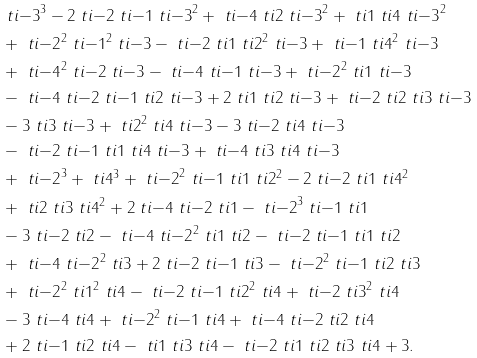Convert formula to latex. <formula><loc_0><loc_0><loc_500><loc_500>& \ t i { - 3 } ^ { 3 } - 2 \ t i { - 2 } \ t i { - 1 } \ t i { - 3 } ^ { 2 } + \ t i { - 4 } \ t i { 2 } \ t i { - 3 } ^ { 2 } + \ t i { 1 } \ t i { 4 } \ t i { - 3 } ^ { 2 } \\ & + \ t i { - 2 } ^ { 2 } \ t i { - 1 } ^ { 2 } \ t i { - 3 } - \ t i { - 2 } \ t i { 1 } \ t i { 2 } ^ { 2 } \ t i { - 3 } + \ t i { - 1 } \ t i { 4 } ^ { 2 } \ t i { - 3 } \\ & + \ t i { - 4 } ^ { 2 } \ t i { - 2 } \ t i { - 3 } - \ t i { - 4 } \ t i { - 1 } \ t i { - 3 } + \ t i { - 2 } ^ { 2 } \ t i { 1 } \ t i { - 3 } \\ & - \ t i { - 4 } \ t i { - 2 } \ t i { - 1 } \ t i { 2 } \ t i { - 3 } + 2 \ t i { 1 } \ t i { 2 } \ t i { - 3 } + \ t i { - 2 } \ t i { 2 } \ t i { 3 } \ t i { - 3 } \\ & - 3 \ t i { 3 } \ t i { - 3 } + \ t i { 2 } ^ { 2 } \ t i { 4 } \ t i { - 3 } - 3 \ t i { - 2 } \ t i { 4 } \ t i { - 3 } \\ & - \ t i { - 2 } \ t i { - 1 } \ t i { 1 } \ t i { 4 } \ t i { - 3 } + \ t i { - 4 } \ t i { 3 } \ t i { 4 } \ t i { - 3 } \\ & + \ t i { - 2 } ^ { 3 } + \ t i { 4 } ^ { 3 } + \ t i { - 2 } ^ { 2 } \ t i { - 1 } \ t i { 1 } \ t i { 2 } ^ { 2 } - 2 \ t i { - 2 } \ t i { 1 } \ t i { 4 } ^ { 2 } \\ & + \ t i { 2 } \ t i { 3 } \ t i { 4 } ^ { 2 } + 2 \ t i { - 4 } \ t i { - 2 } \ t i { 1 } - \ t i { - 2 } ^ { 3 } \ t i { - 1 } \ t i { 1 } \\ & - 3 \ t i { - 2 } \ t i { 2 } - \ t i { - 4 } \ t i { - 2 } ^ { 2 } \ t i { 1 } \ t i { 2 } - \ t i { - 2 } \ t i { - 1 } \ t i { 1 } \ t i { 2 } \\ & + \ t i { - 4 } \ t i { - 2 } ^ { 2 } \ t i { 3 } + 2 \ t i { - 2 } \ t i { - 1 } \ t i { 3 } - \ t i { - 2 } ^ { 2 } \ t i { - 1 } \ t i { 2 } \ t i { 3 } \\ & + \ t i { - 2 } ^ { 2 } \ t i { 1 } ^ { 2 } \ t i { 4 } - \ t i { - 2 } \ t i { - 1 } \ t i { 2 } ^ { 2 } \ t i { 4 } + \ t i { - 2 } \ t i { 3 } ^ { 2 } \ t i { 4 } \\ & - 3 \ t i { - 4 } \ t i { 4 } + \ t i { - 2 } ^ { 2 } \ t i { - 1 } \ t i { 4 } + \ t i { - 4 } \ t i { - 2 } \ t i { 2 } \ t i { 4 } \\ & + 2 \ t i { - 1 } \ t i { 2 } \ t i { 4 } - \ t i { 1 } \ t i { 3 } \ t i { 4 } - \ t i { - 2 } \ t i { 1 } \ t i { 2 } \ t i { 3 } \ t i { 4 } + 3 .</formula> 